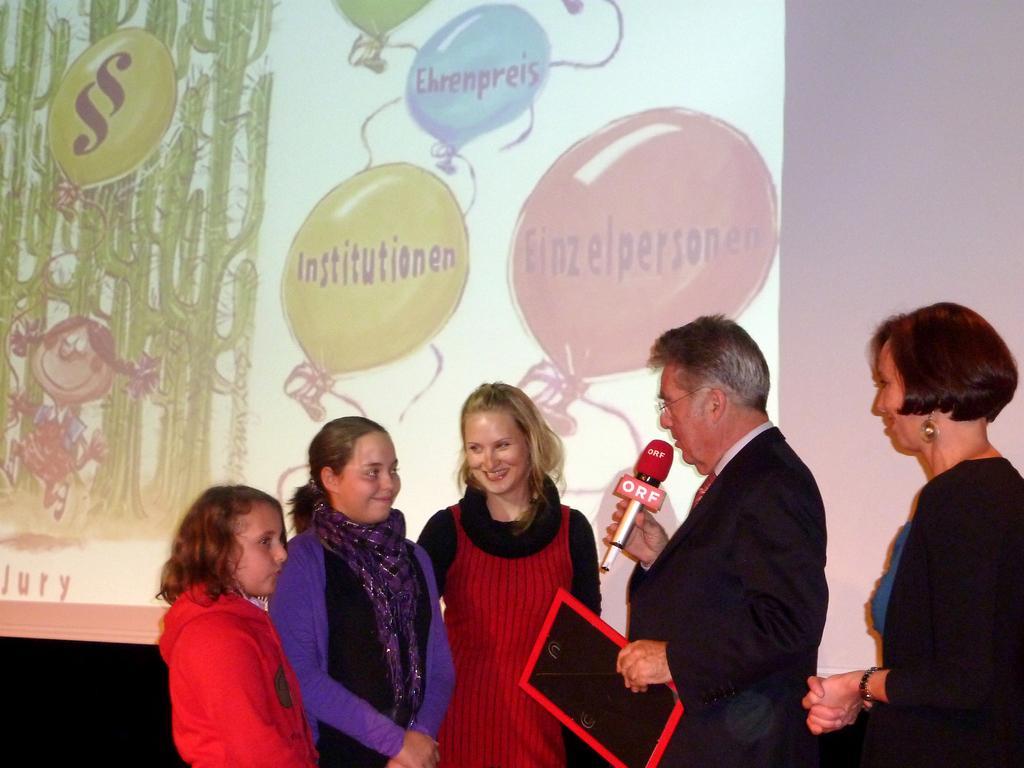Describe this image in one or two sentences. In this image in front there are a few people standing on the floor. Behind them there is a banner. 